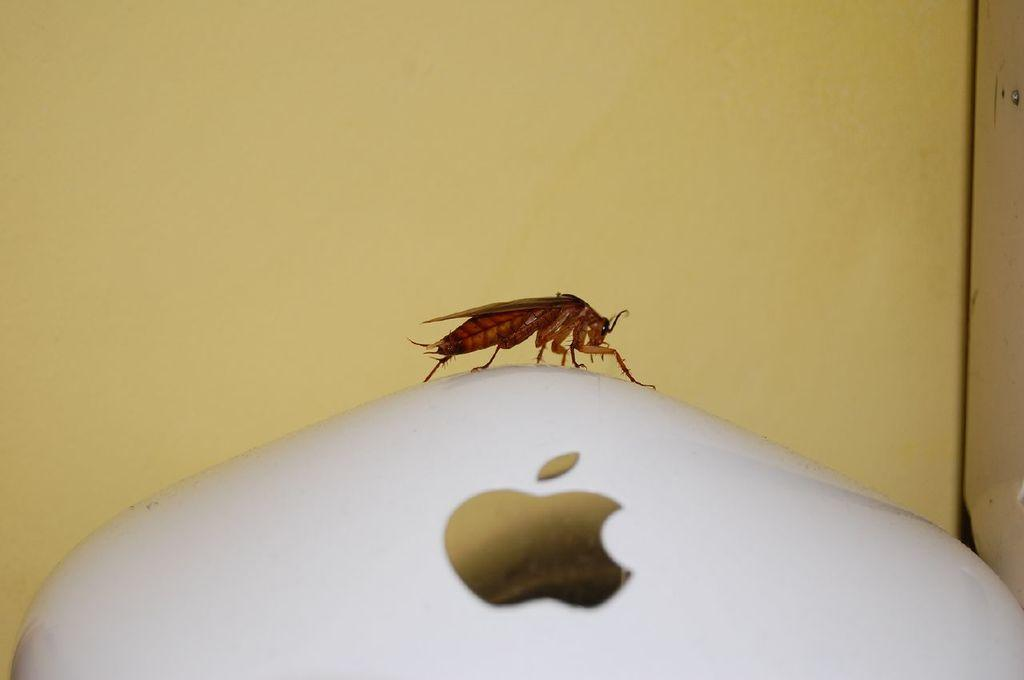What is the main subject of the image? The main subject of the image is a cockroach. Where is the cockroach located in the image? The cockroach is in the center of the image. Is the cockroach on a specific object or surface? Yes, the cockroach is on an object. What type of bird is perched on the grandfather's shoulder in the image? There is no bird or grandfather present in the image; it only features a cockroach. 